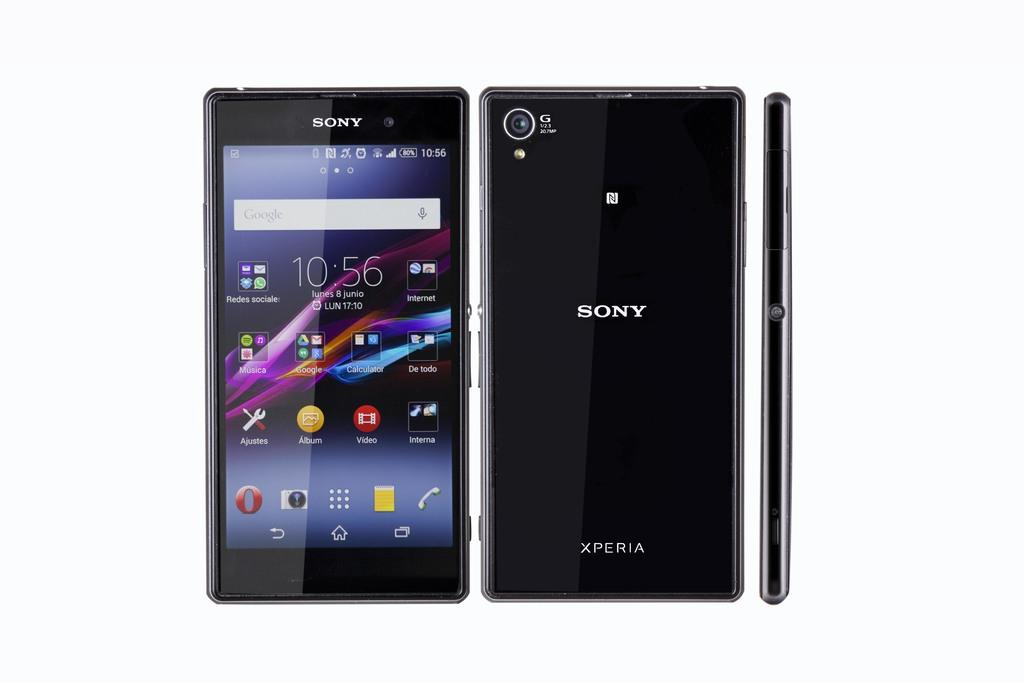<image>
Give a short and clear explanation of the subsequent image. A black sony cell phone with apps on it. 